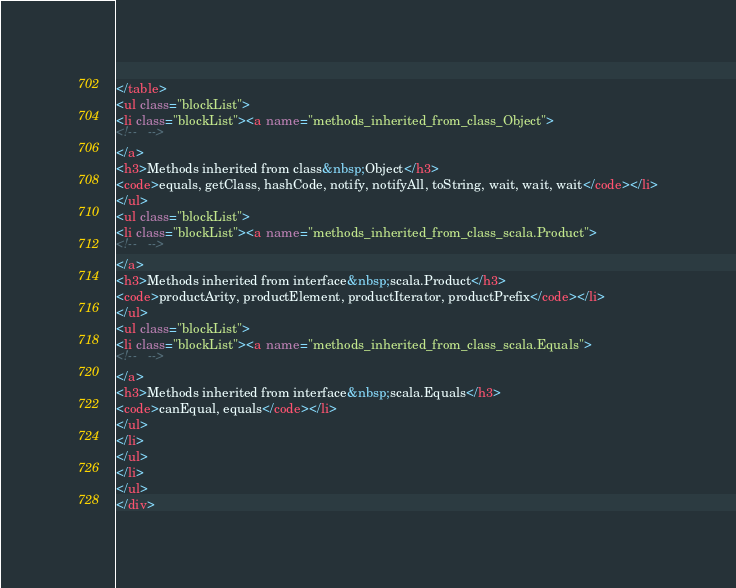Convert code to text. <code><loc_0><loc_0><loc_500><loc_500><_HTML_></table>
<ul class="blockList">
<li class="blockList"><a name="methods_inherited_from_class_Object">
<!--   -->
</a>
<h3>Methods inherited from class&nbsp;Object</h3>
<code>equals, getClass, hashCode, notify, notifyAll, toString, wait, wait, wait</code></li>
</ul>
<ul class="blockList">
<li class="blockList"><a name="methods_inherited_from_class_scala.Product">
<!--   -->
</a>
<h3>Methods inherited from interface&nbsp;scala.Product</h3>
<code>productArity, productElement, productIterator, productPrefix</code></li>
</ul>
<ul class="blockList">
<li class="blockList"><a name="methods_inherited_from_class_scala.Equals">
<!--   -->
</a>
<h3>Methods inherited from interface&nbsp;scala.Equals</h3>
<code>canEqual, equals</code></li>
</ul>
</li>
</ul>
</li>
</ul>
</div></code> 